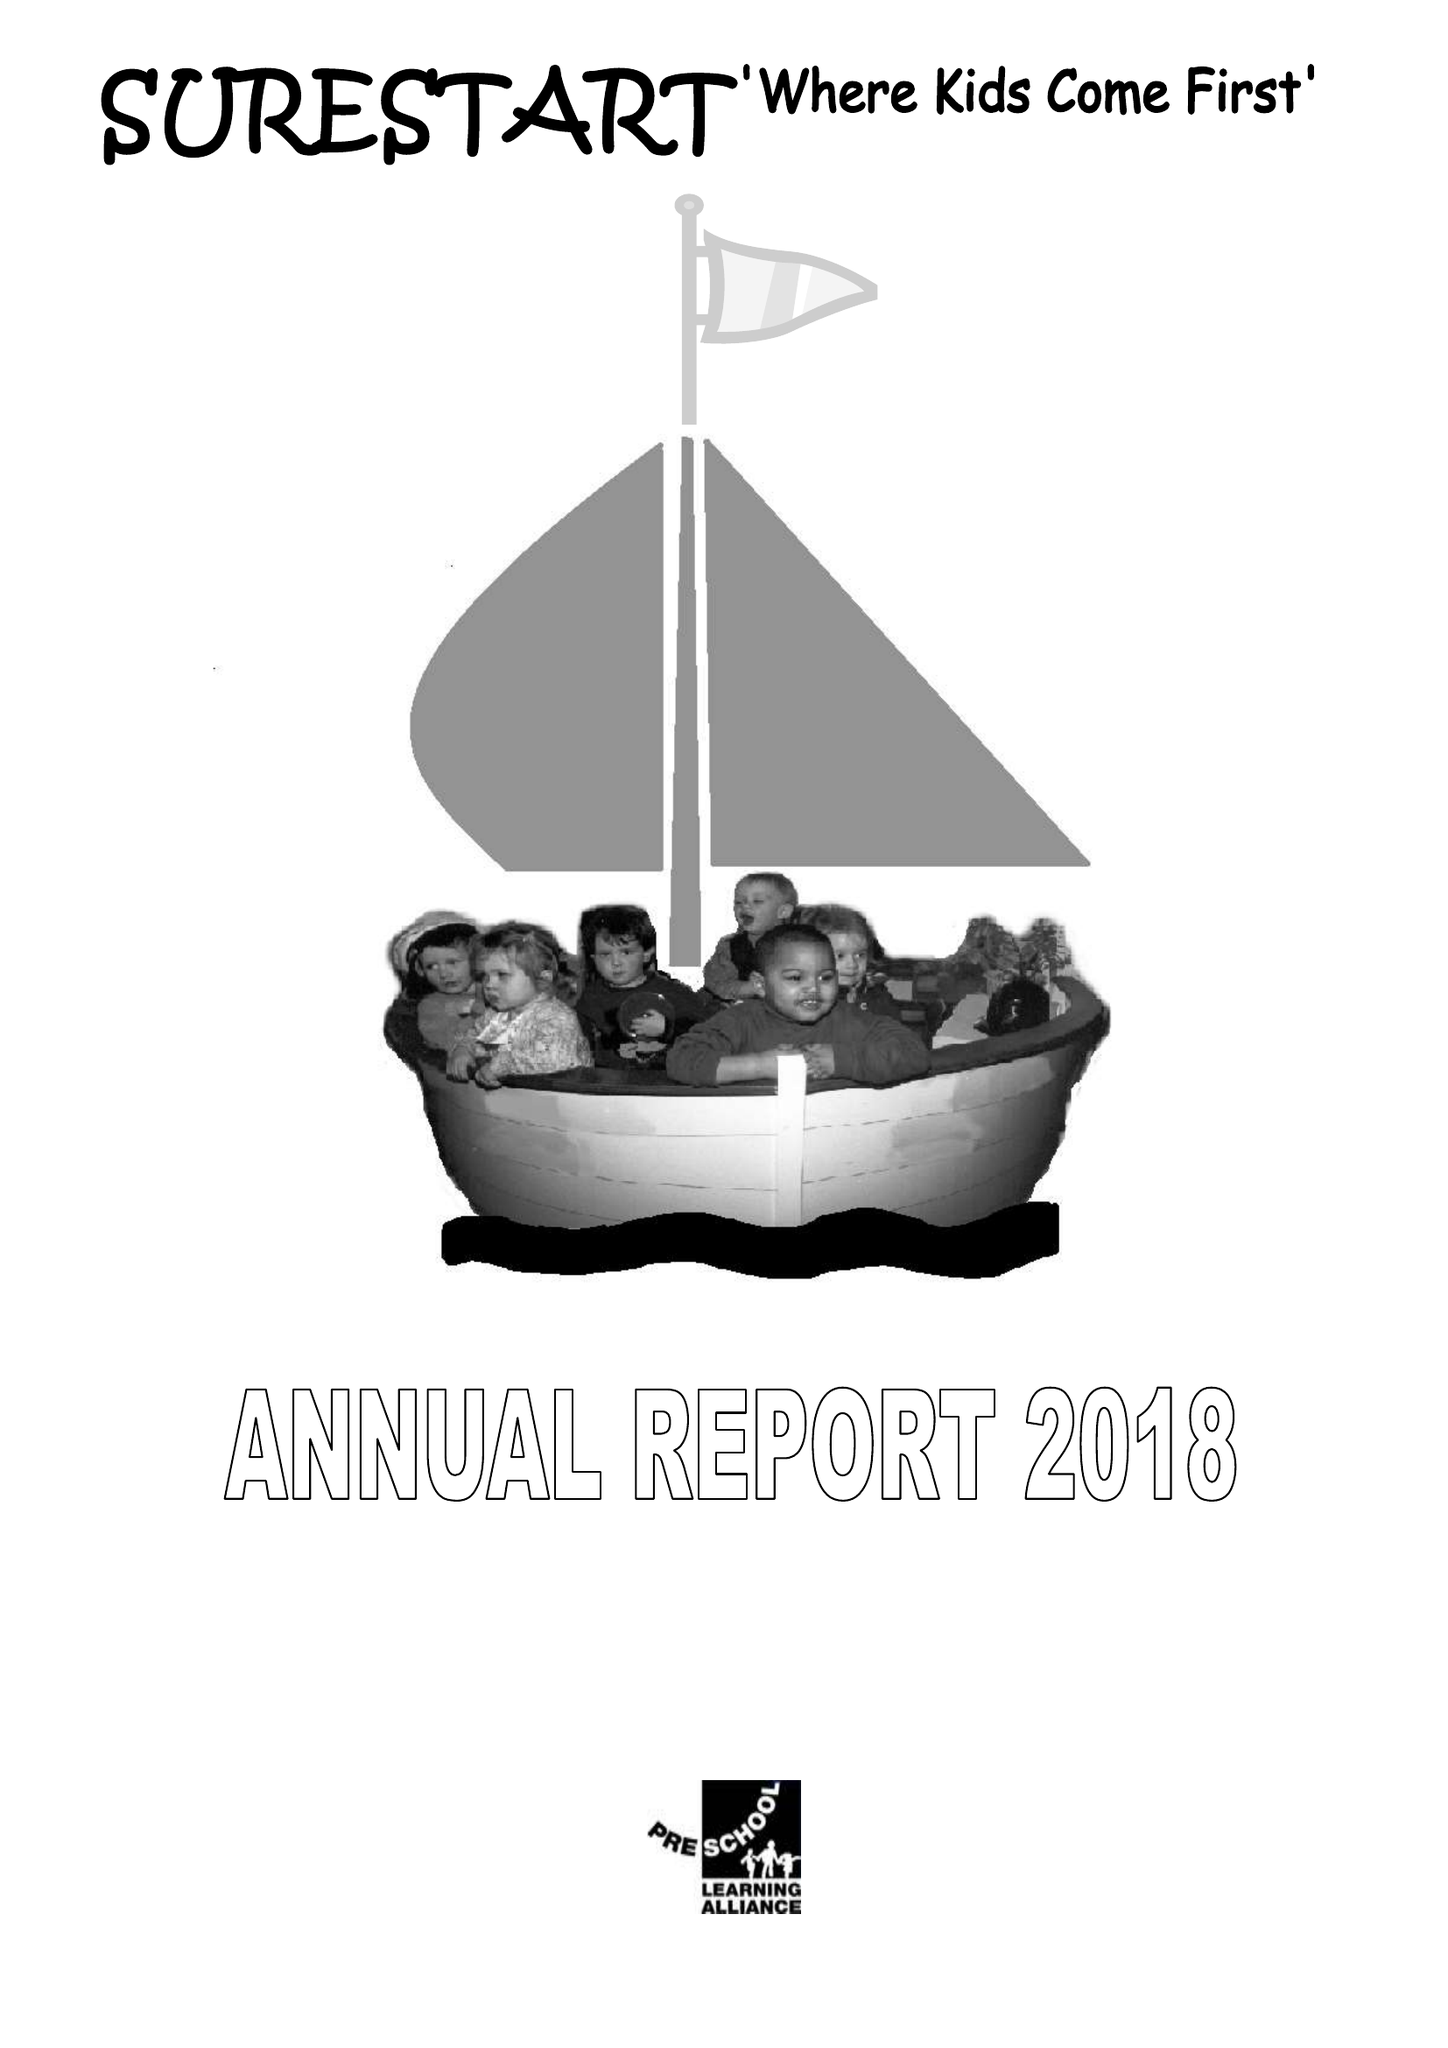What is the value for the income_annually_in_british_pounds?
Answer the question using a single word or phrase. 231537.00 